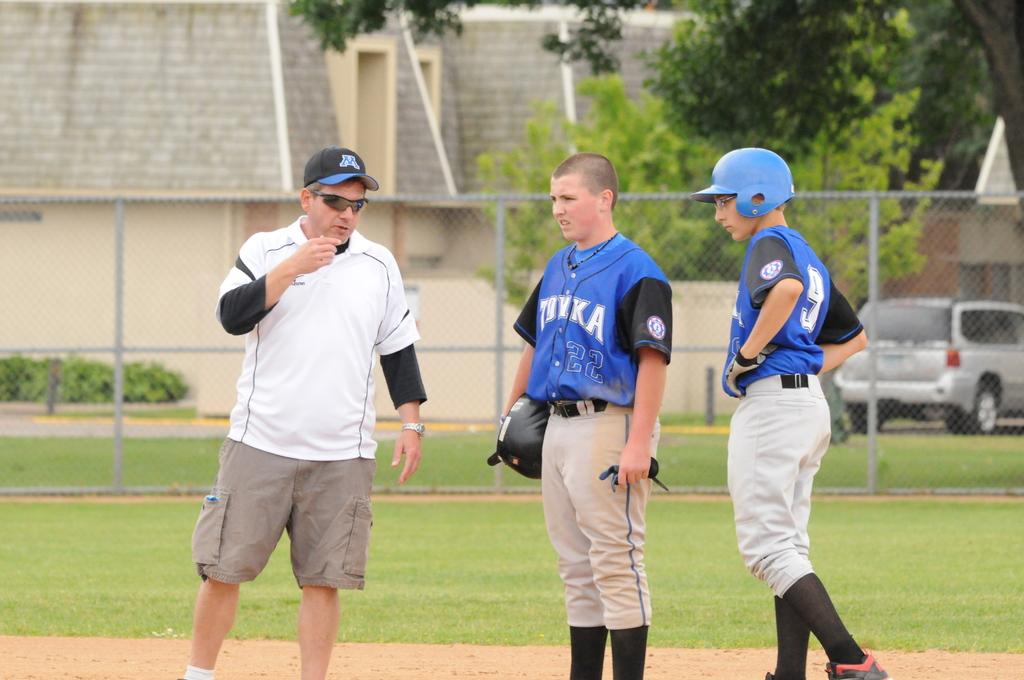What letter is on the cap?
Make the answer very short. M. 